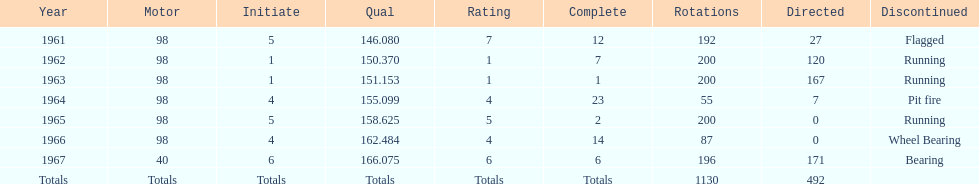In which years did he lead the race the least? 1965, 1966. 